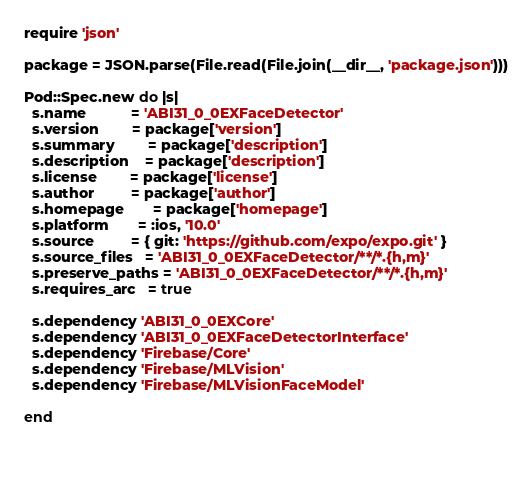<code> <loc_0><loc_0><loc_500><loc_500><_Ruby_>require 'json'

package = JSON.parse(File.read(File.join(__dir__, 'package.json')))

Pod::Spec.new do |s|
  s.name           = 'ABI31_0_0EXFaceDetector'
  s.version        = package['version']
  s.summary        = package['description']
  s.description    = package['description']
  s.license        = package['license']
  s.author         = package['author']
  s.homepage       = package['homepage']
  s.platform       = :ios, '10.0'
  s.source         = { git: 'https://github.com/expo/expo.git' }
  s.source_files   = 'ABI31_0_0EXFaceDetector/**/*.{h,m}'
  s.preserve_paths = 'ABI31_0_0EXFaceDetector/**/*.{h,m}'
  s.requires_arc   = true

  s.dependency 'ABI31_0_0EXCore'
  s.dependency 'ABI31_0_0EXFaceDetectorInterface'
  s.dependency 'Firebase/Core'
  s.dependency 'Firebase/MLVision'
  s.dependency 'Firebase/MLVisionFaceModel'

end

  
</code> 